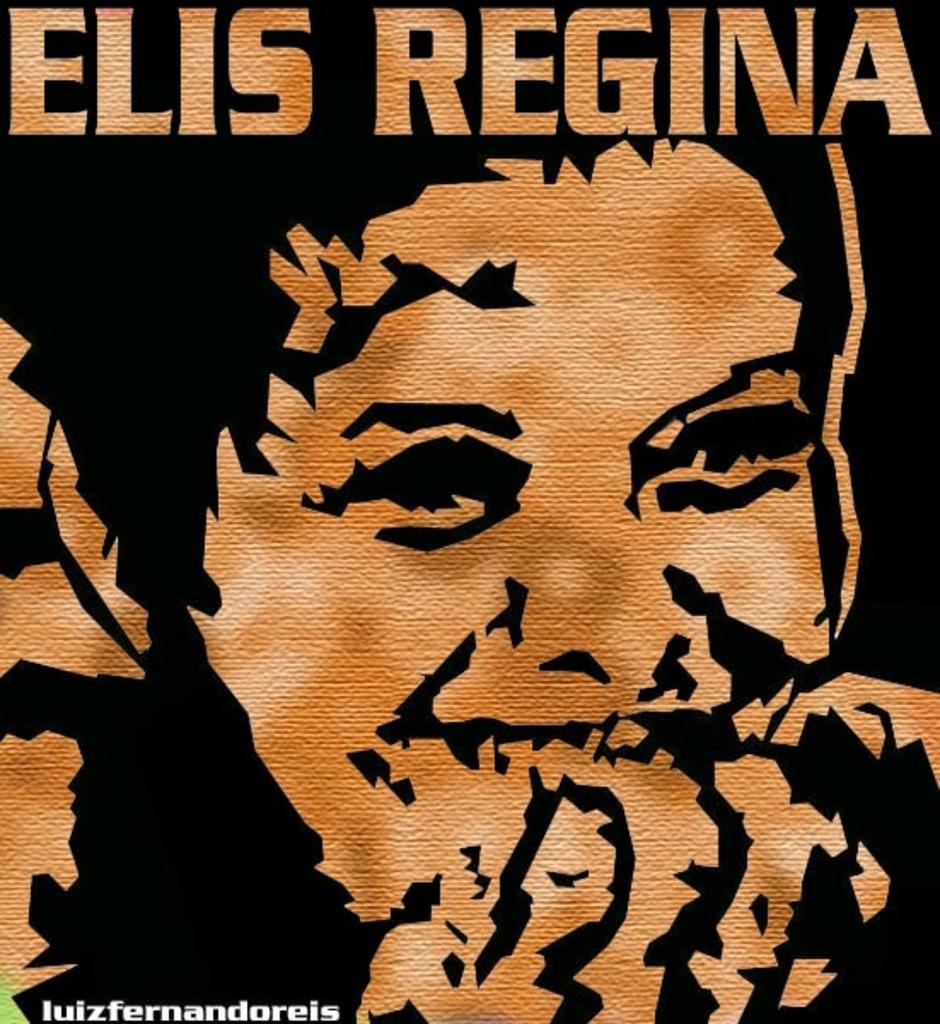What is featured on the poster in the image? There is a poster in the image, and it contains a person's face. What expression does the person in the poster have? The person in the poster is smiling. Is there any text or symbol on the poster? Yes, there is a watermark in the bottom left corner of the poster. What type of beds can be seen in the image? There are no beds present in the image; it features a poster with a person's face. What is the purpose of the person driving in the image? There is no person driving in the image; it only contains a poster with a person's face. 